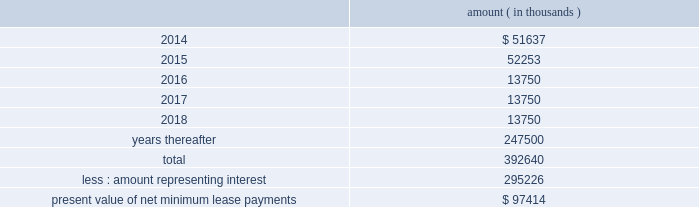Entergy corporation and subsidiaries notes to financial statements this difference as a regulatory asset or liability on an ongoing basis , resulting in a zero net balance for the regulatory asset at the end of the lease term .
The amount was a net regulatory liability of $ 61.6 million and $ 27.8 million as of december 31 , 2013 and 2012 , respectively .
As of december 31 , 2013 , system energy had future minimum lease payments ( reflecting an implicit rate of 5.13% ( 5.13 % ) ) , which are recorded as long-term debt , as follows : amount ( in thousands ) .

What portion of the total future minimum lease payments represent the interest for system energy? 
Computations: (295226 / 392640)
Answer: 0.7519. 